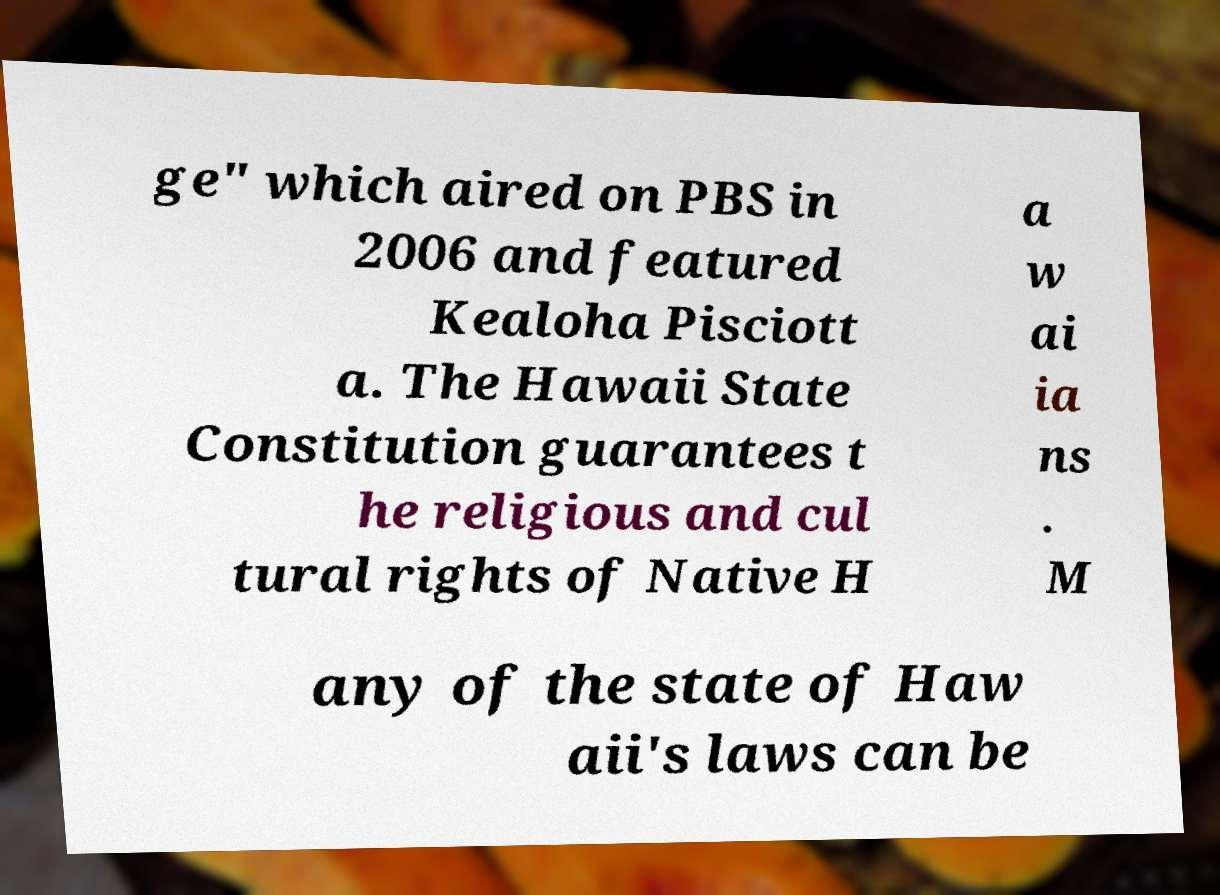Please read and relay the text visible in this image. What does it say? ge" which aired on PBS in 2006 and featured Kealoha Pisciott a. The Hawaii State Constitution guarantees t he religious and cul tural rights of Native H a w ai ia ns . M any of the state of Haw aii's laws can be 